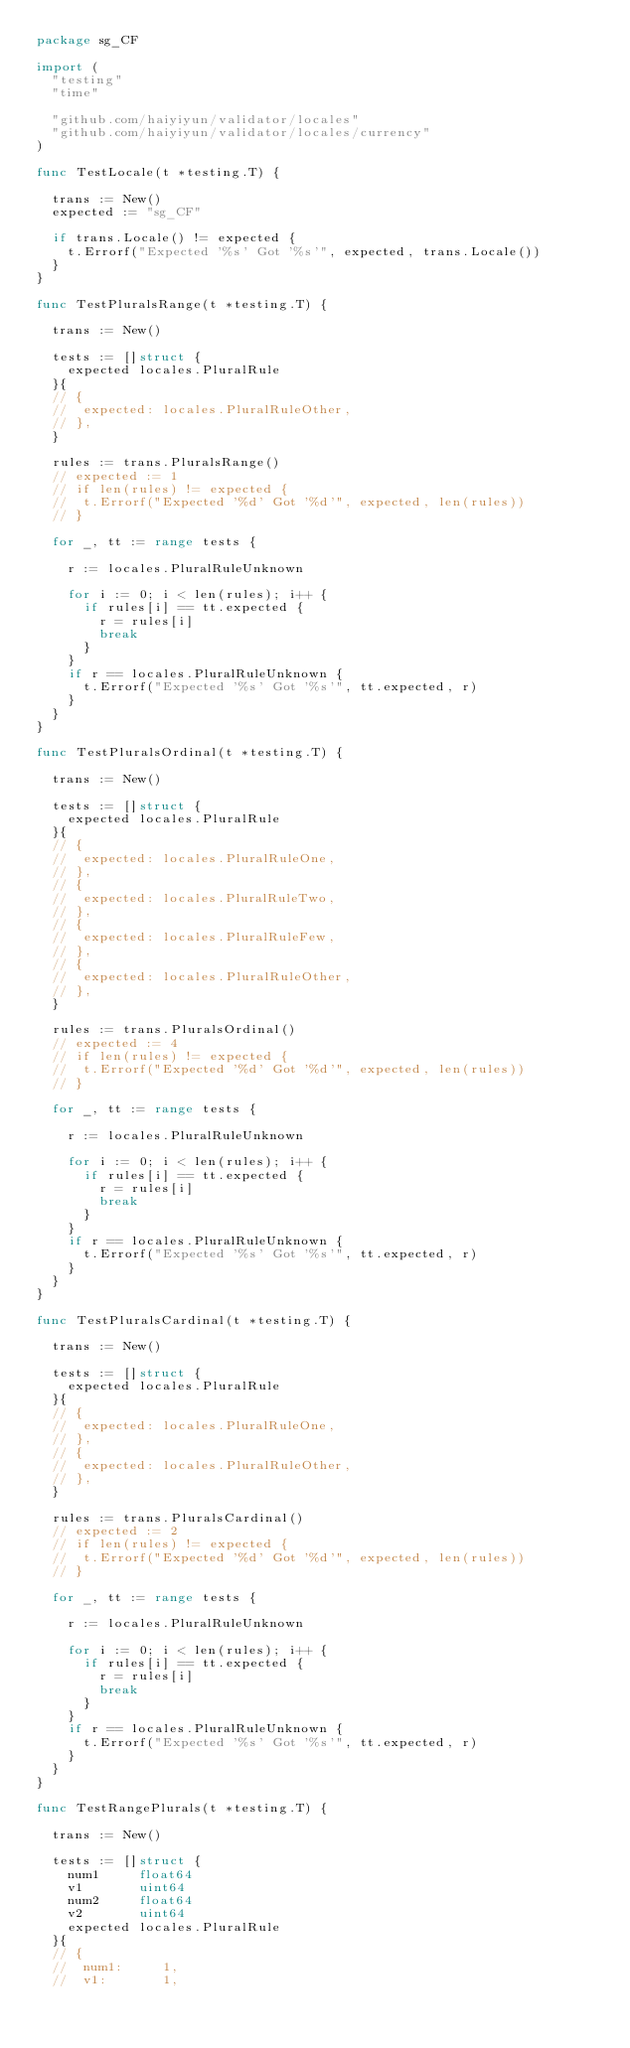Convert code to text. <code><loc_0><loc_0><loc_500><loc_500><_Go_>package sg_CF

import (
	"testing"
	"time"

	"github.com/haiyiyun/validator/locales"
	"github.com/haiyiyun/validator/locales/currency"
)

func TestLocale(t *testing.T) {

	trans := New()
	expected := "sg_CF"

	if trans.Locale() != expected {
		t.Errorf("Expected '%s' Got '%s'", expected, trans.Locale())
	}
}

func TestPluralsRange(t *testing.T) {

	trans := New()

	tests := []struct {
		expected locales.PluralRule
	}{
	// {
	// 	expected: locales.PluralRuleOther,
	// },
	}

	rules := trans.PluralsRange()
	// expected := 1
	// if len(rules) != expected {
	// 	t.Errorf("Expected '%d' Got '%d'", expected, len(rules))
	// }

	for _, tt := range tests {

		r := locales.PluralRuleUnknown

		for i := 0; i < len(rules); i++ {
			if rules[i] == tt.expected {
				r = rules[i]
				break
			}
		}
		if r == locales.PluralRuleUnknown {
			t.Errorf("Expected '%s' Got '%s'", tt.expected, r)
		}
	}
}

func TestPluralsOrdinal(t *testing.T) {

	trans := New()

	tests := []struct {
		expected locales.PluralRule
	}{
	// {
	// 	expected: locales.PluralRuleOne,
	// },
	// {
	// 	expected: locales.PluralRuleTwo,
	// },
	// {
	// 	expected: locales.PluralRuleFew,
	// },
	// {
	// 	expected: locales.PluralRuleOther,
	// },
	}

	rules := trans.PluralsOrdinal()
	// expected := 4
	// if len(rules) != expected {
	// 	t.Errorf("Expected '%d' Got '%d'", expected, len(rules))
	// }

	for _, tt := range tests {

		r := locales.PluralRuleUnknown

		for i := 0; i < len(rules); i++ {
			if rules[i] == tt.expected {
				r = rules[i]
				break
			}
		}
		if r == locales.PluralRuleUnknown {
			t.Errorf("Expected '%s' Got '%s'", tt.expected, r)
		}
	}
}

func TestPluralsCardinal(t *testing.T) {

	trans := New()

	tests := []struct {
		expected locales.PluralRule
	}{
	// {
	// 	expected: locales.PluralRuleOne,
	// },
	// {
	// 	expected: locales.PluralRuleOther,
	// },
	}

	rules := trans.PluralsCardinal()
	// expected := 2
	// if len(rules) != expected {
	// 	t.Errorf("Expected '%d' Got '%d'", expected, len(rules))
	// }

	for _, tt := range tests {

		r := locales.PluralRuleUnknown

		for i := 0; i < len(rules); i++ {
			if rules[i] == tt.expected {
				r = rules[i]
				break
			}
		}
		if r == locales.PluralRuleUnknown {
			t.Errorf("Expected '%s' Got '%s'", tt.expected, r)
		}
	}
}

func TestRangePlurals(t *testing.T) {

	trans := New()

	tests := []struct {
		num1     float64
		v1       uint64
		num2     float64
		v2       uint64
		expected locales.PluralRule
	}{
	// {
	// 	num1:     1,
	// 	v1:       1,</code> 